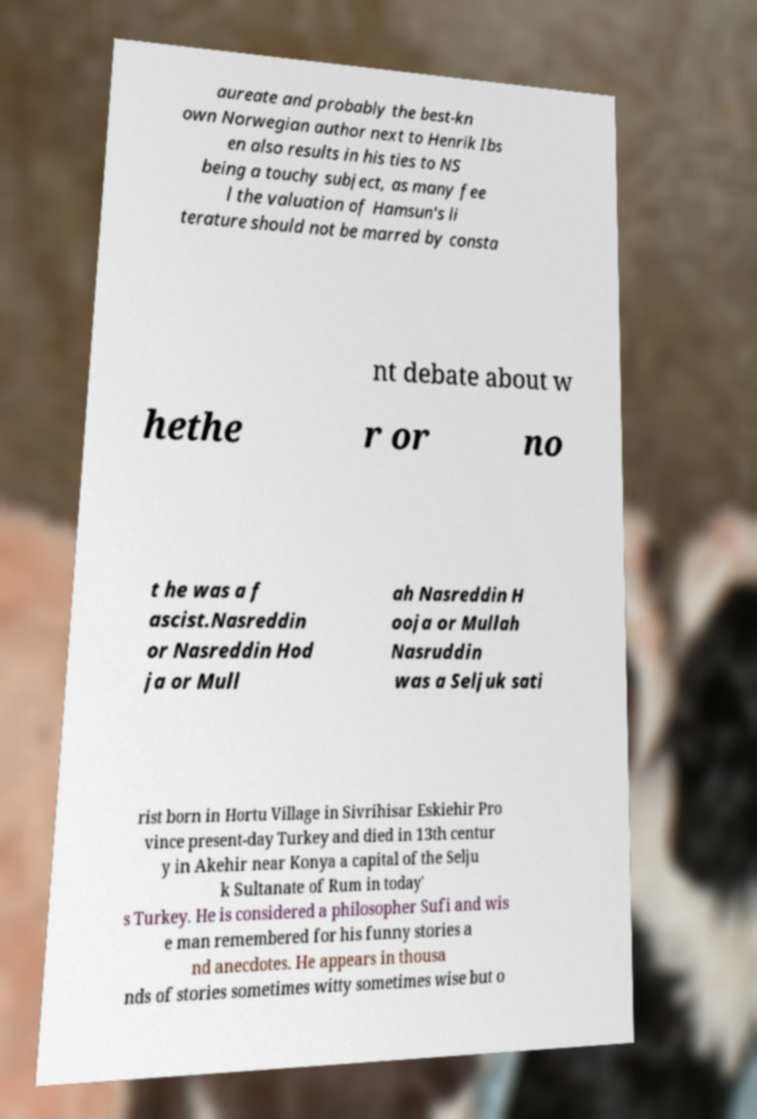Could you assist in decoding the text presented in this image and type it out clearly? aureate and probably the best-kn own Norwegian author next to Henrik Ibs en also results in his ties to NS being a touchy subject, as many fee l the valuation of Hamsun's li terature should not be marred by consta nt debate about w hethe r or no t he was a f ascist.Nasreddin or Nasreddin Hod ja or Mull ah Nasreddin H ooja or Mullah Nasruddin was a Seljuk sati rist born in Hortu Village in Sivrihisar Eskiehir Pro vince present-day Turkey and died in 13th centur y in Akehir near Konya a capital of the Selju k Sultanate of Rum in today' s Turkey. He is considered a philosopher Sufi and wis e man remembered for his funny stories a nd anecdotes. He appears in thousa nds of stories sometimes witty sometimes wise but o 